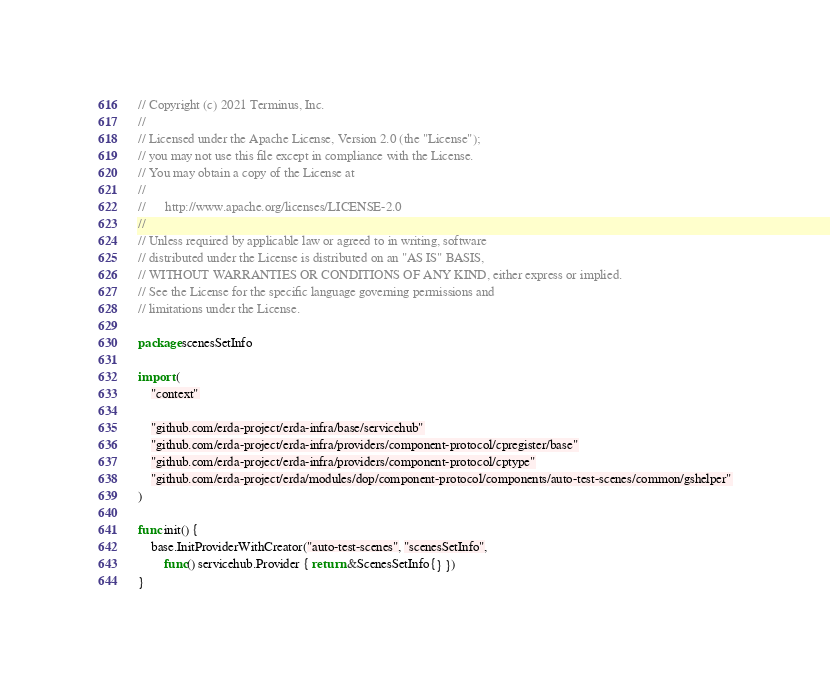Convert code to text. <code><loc_0><loc_0><loc_500><loc_500><_Go_>// Copyright (c) 2021 Terminus, Inc.
//
// Licensed under the Apache License, Version 2.0 (the "License");
// you may not use this file except in compliance with the License.
// You may obtain a copy of the License at
//
//      http://www.apache.org/licenses/LICENSE-2.0
//
// Unless required by applicable law or agreed to in writing, software
// distributed under the License is distributed on an "AS IS" BASIS,
// WITHOUT WARRANTIES OR CONDITIONS OF ANY KIND, either express or implied.
// See the License for the specific language governing permissions and
// limitations under the License.

package scenesSetInfo

import (
	"context"

	"github.com/erda-project/erda-infra/base/servicehub"
	"github.com/erda-project/erda-infra/providers/component-protocol/cpregister/base"
	"github.com/erda-project/erda-infra/providers/component-protocol/cptype"
	"github.com/erda-project/erda/modules/dop/component-protocol/components/auto-test-scenes/common/gshelper"
)

func init() {
	base.InitProviderWithCreator("auto-test-scenes", "scenesSetInfo",
		func() servicehub.Provider { return &ScenesSetInfo{} })
}
</code> 